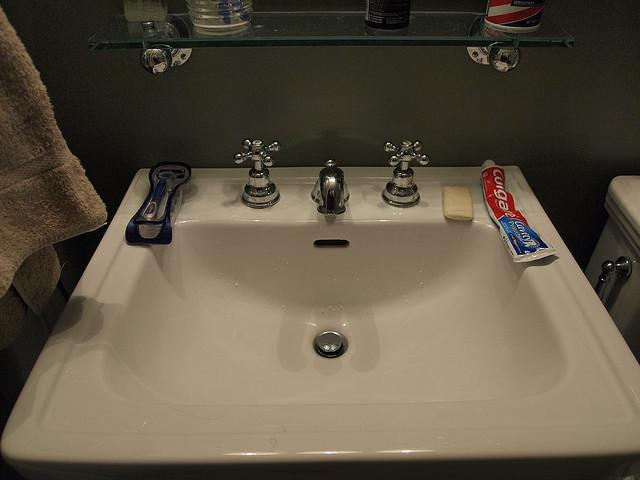What will they squeeze the substance in the tube onto? toothbrush 